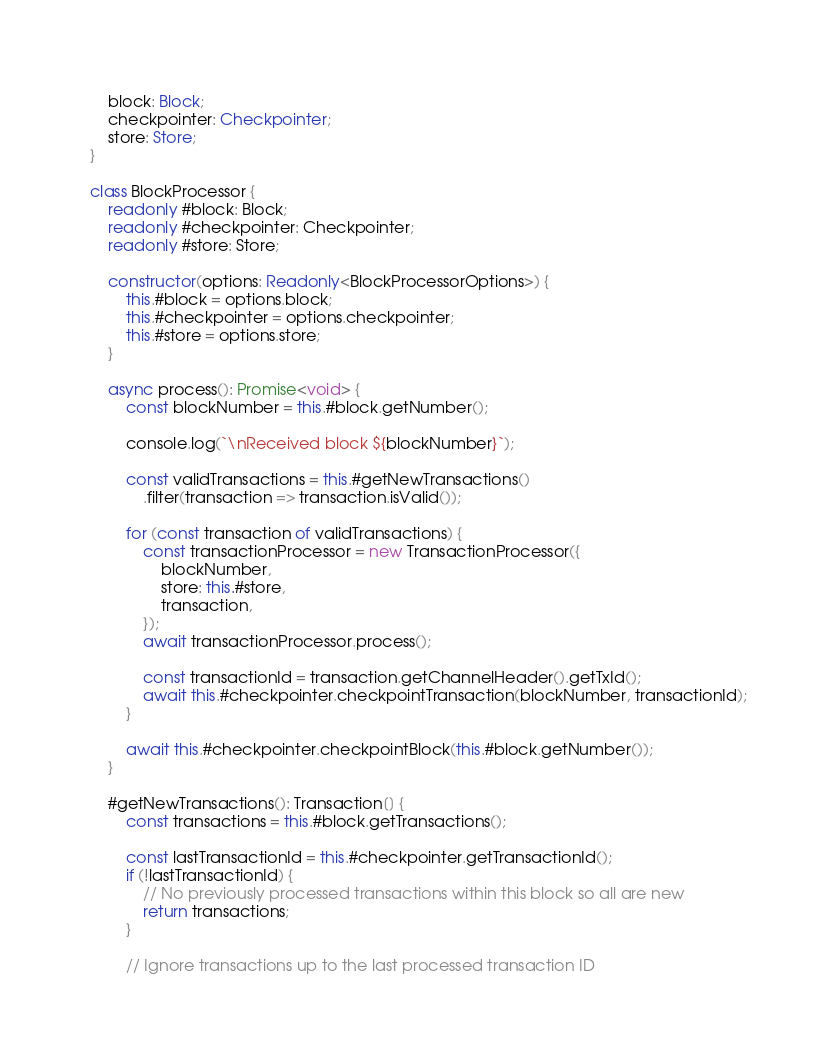<code> <loc_0><loc_0><loc_500><loc_500><_TypeScript_>    block: Block;
    checkpointer: Checkpointer;
    store: Store;
}

class BlockProcessor {
    readonly #block: Block;
    readonly #checkpointer: Checkpointer;
    readonly #store: Store;

    constructor(options: Readonly<BlockProcessorOptions>) {
        this.#block = options.block;
        this.#checkpointer = options.checkpointer;
        this.#store = options.store;
    }

    async process(): Promise<void> {
        const blockNumber = this.#block.getNumber();

        console.log(`\nReceived block ${blockNumber}`);

        const validTransactions = this.#getNewTransactions()
            .filter(transaction => transaction.isValid());

        for (const transaction of validTransactions) {
            const transactionProcessor = new TransactionProcessor({
                blockNumber,
                store: this.#store,
                transaction,
            });
            await transactionProcessor.process();

            const transactionId = transaction.getChannelHeader().getTxId();
            await this.#checkpointer.checkpointTransaction(blockNumber, transactionId);
        }

        await this.#checkpointer.checkpointBlock(this.#block.getNumber());
    }

    #getNewTransactions(): Transaction[] {
        const transactions = this.#block.getTransactions();

        const lastTransactionId = this.#checkpointer.getTransactionId();
        if (!lastTransactionId) {
            // No previously processed transactions within this block so all are new
            return transactions;
        }

        // Ignore transactions up to the last processed transaction ID</code> 